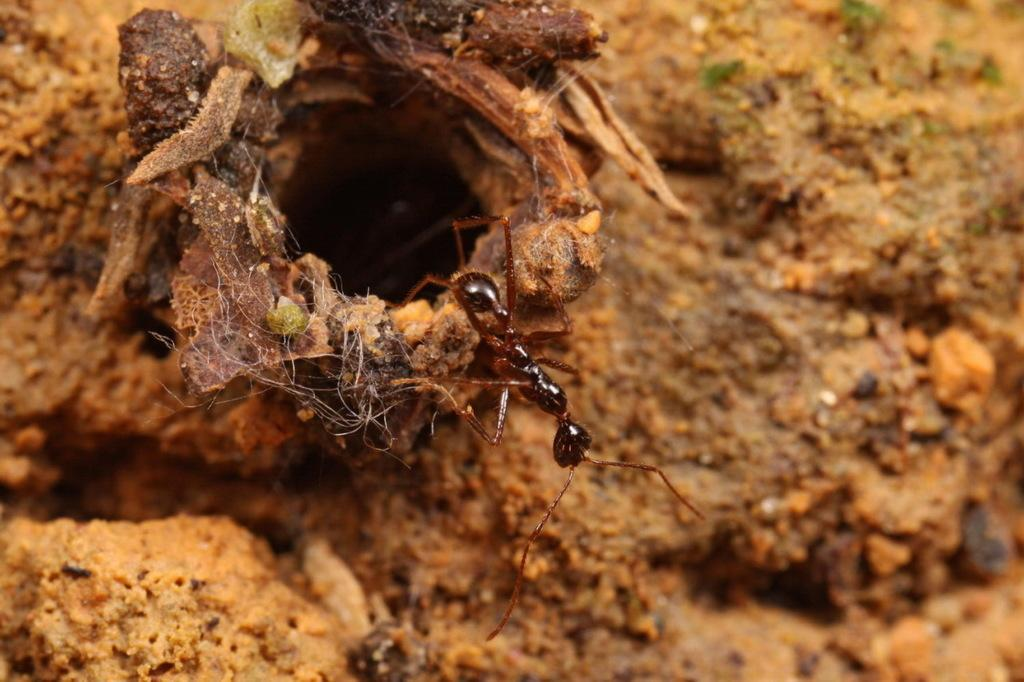What is the main subject of the image? The main subject of the image is an ant. Where is the ant coming from? The ant is coming out from an ant colony. What type of environment is visible in the background of the image? There is a soil land in the background of the image. How many bushes can be seen in the image? There are no bushes present in the image; it features an ant coming out from an ant colony in a soil land. Is the rabbit in the image trying to stop the ant from moving? There is no rabbit present in the image. 